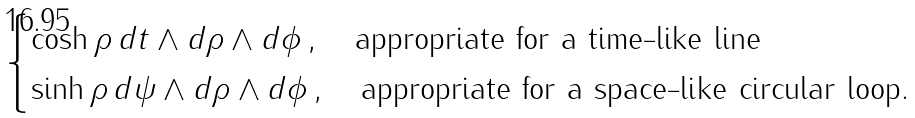Convert formula to latex. <formula><loc_0><loc_0><loc_500><loc_500>\begin{cases} \cosh \rho \, d t \wedge d \rho \wedge d \phi \, , \quad \text {appropriate for a time-like line} \\ \sinh \rho \, d \psi \wedge d \rho \wedge d \phi \, , \quad \text {appropriate for a space-like circular loop.} \end{cases}</formula> 